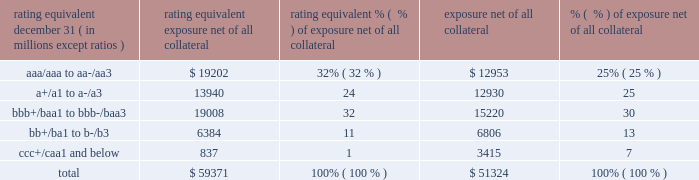Management 2019s discussion and analysis 126 jpmorgan chase & co./2014 annual report while useful as a current view of credit exposure , the net fair value of the derivative receivables does not capture the potential future variability of that credit exposure .
To capture the potential future variability of credit exposure , the firm calculates , on a client-by-client basis , three measures of potential derivatives-related credit loss : peak , derivative risk equivalent ( 201cdre 201d ) , and average exposure ( 201cavg 201d ) .
These measures all incorporate netting and collateral benefits , where applicable .
Peak exposure to a counterparty is an extreme measure of exposure calculated at a 97.5% ( 97.5 % ) confidence level .
Dre exposure is a measure that expresses the risk of derivative exposure on a basis intended to be equivalent to the risk of loan exposures .
The measurement is done by equating the unexpected loss in a derivative counterparty exposure ( which takes into consideration both the loss volatility and the credit rating of the counterparty ) with the unexpected loss in a loan exposure ( which takes into consideration only the credit rating of the counterparty ) .
Dre is a less extreme measure of potential credit loss than peak and is the primary measure used by the firm for credit approval of derivative transactions .
Finally , avg is a measure of the expected fair value of the firm 2019s derivative receivables at future time periods , including the benefit of collateral .
Avg exposure over the total life of the derivative contract is used as the primary metric for pricing purposes and is used to calculate credit capital and the cva , as further described below .
The three year avg exposure was $ 37.5 billion and $ 35.4 billion at december 31 , 2014 and 2013 , respectively , compared with derivative receivables , net of all collateral , of $ 59.4 billion and $ 51.3 billion at december 31 , 2014 and 2013 , respectively .
The fair value of the firm 2019s derivative receivables incorporates an adjustment , the cva , to reflect the credit quality of counterparties .
The cva is based on the firm 2019s avg to a counterparty and the counterparty 2019s credit spread in the credit derivatives market .
The primary components of changes in cva are credit spreads , new deal activity or unwinds , and changes in the underlying market environment .
The firm believes that active risk management is essential to controlling the dynamic credit risk in the derivatives portfolio .
In addition , the firm 2019s risk management process takes into consideration the potential impact of wrong-way risk , which is broadly defined as the potential for increased correlation between the firm 2019s exposure to a counterparty ( avg ) and the counterparty 2019s credit quality .
Many factors may influence the nature and magnitude of these correlations over time .
To the extent that these correlations are identified , the firm may adjust the cva associated with that counterparty 2019s avg .
The firm risk manages exposure to changes in cva by entering into credit derivative transactions , as well as interest rate , foreign exchange , equity and commodity derivative transactions .
The accompanying graph shows exposure profiles to the firm 2019s current derivatives portfolio over the next 10 years as calculated by the dre and avg metrics .
The two measures generally show that exposure will decline after the first year , if no new trades are added to the portfolio .
The table summarizes the ratings profile by derivative counterparty of the firm 2019s derivative receivables , including credit derivatives , net of other liquid securities collateral , for the dates indicated .
The ratings scale is based on the firm 2019s internal ratings , which generally correspond to the ratings as defined by s&p and moody 2019s .
Ratings profile of derivative receivables rating equivalent 2014 2013 ( a ) december 31 , ( in millions , except ratios ) exposure net of all collateral % (  % ) of exposure net of all collateral exposure net of all collateral % (  % ) of exposure net of all collateral .
( a ) the prior period amounts have been revised to conform with the current period presentation. .
What percentage of the total exposure net of all collateral has a rating equivalent of a+/a1 to a-/a3? 
Computations: (13940 / 59371)
Answer: 0.23479. 